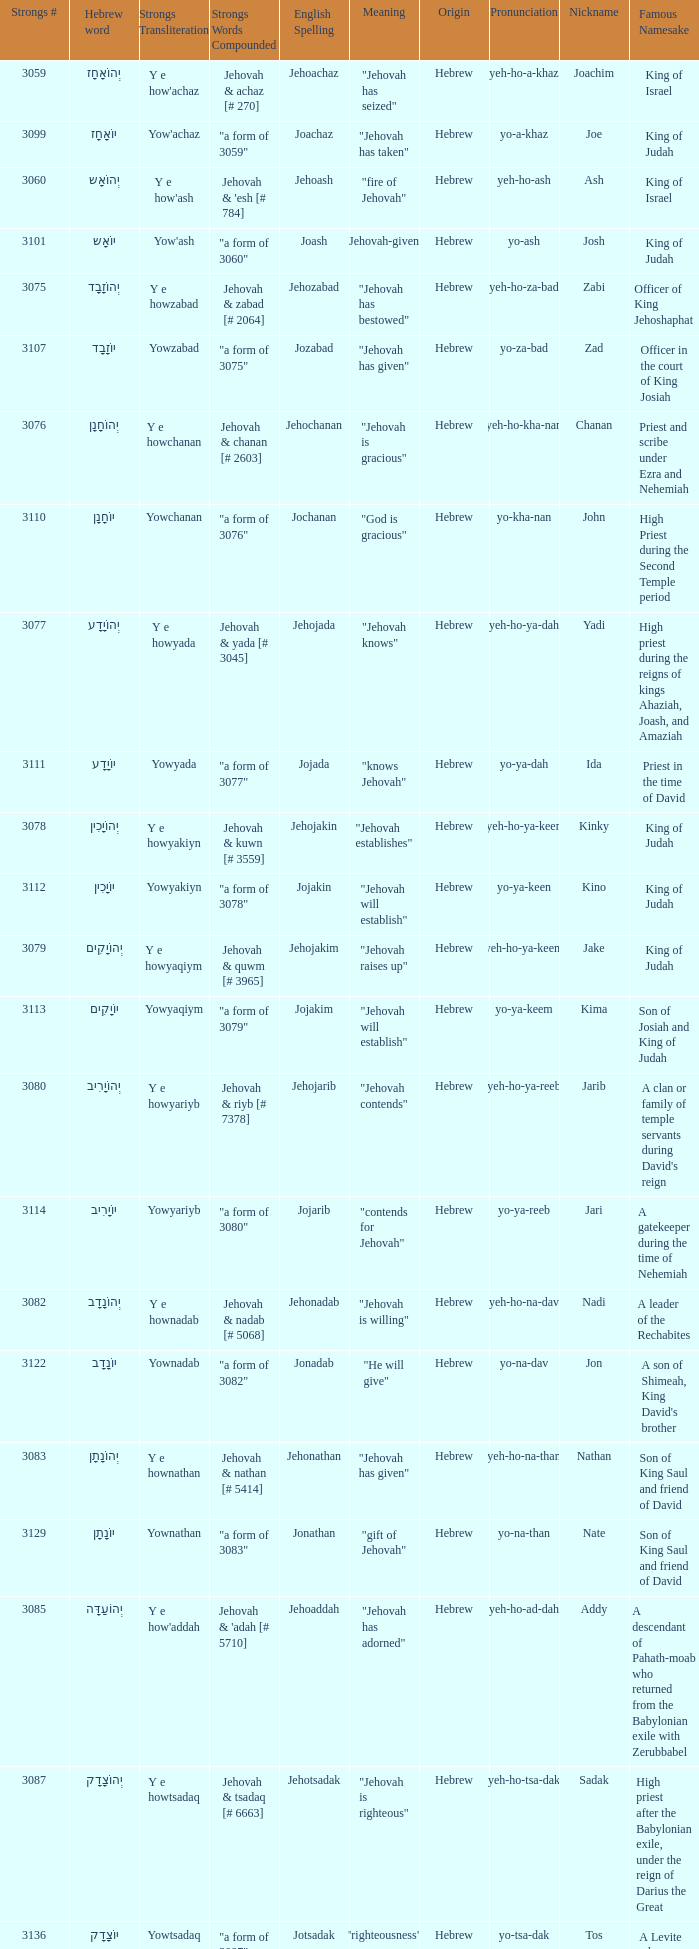What is the strong words compounded when the strongs transliteration is yowyariyb? "a form of 3080". 